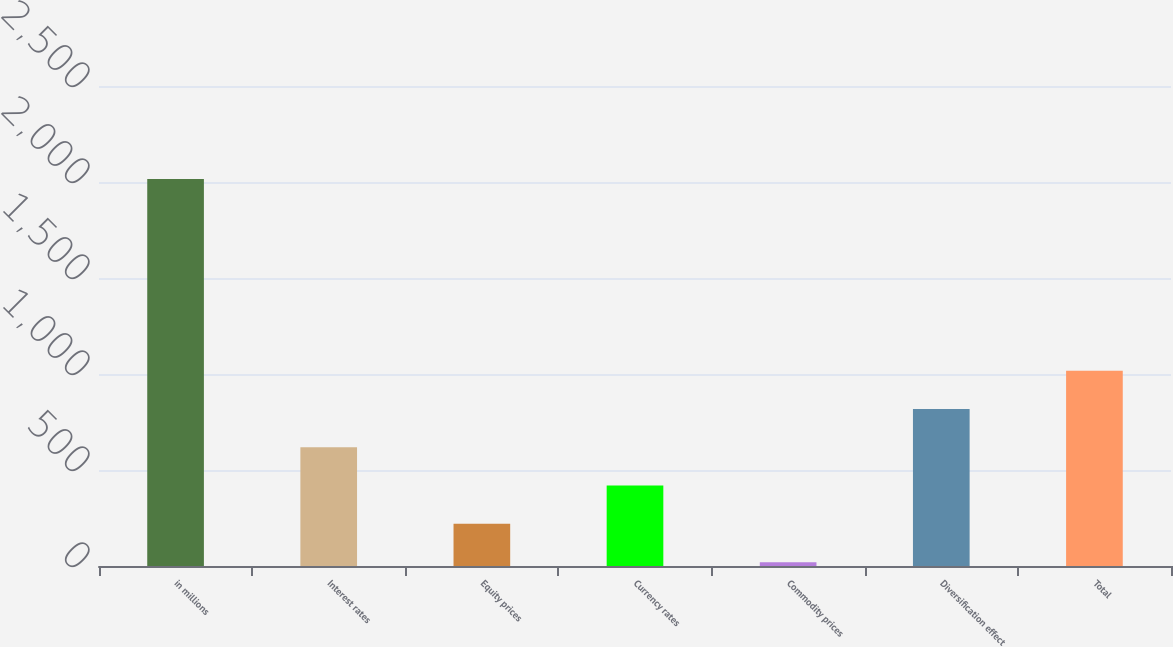Convert chart. <chart><loc_0><loc_0><loc_500><loc_500><bar_chart><fcel>in millions<fcel>Interest rates<fcel>Equity prices<fcel>Currency rates<fcel>Commodity prices<fcel>Diversification effect<fcel>Total<nl><fcel>2015<fcel>618.5<fcel>219.5<fcel>419<fcel>20<fcel>818<fcel>1017.5<nl></chart> 